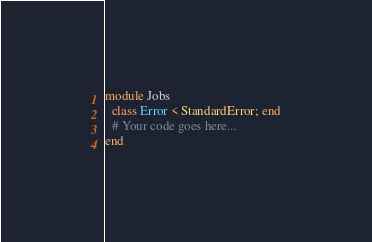<code> <loc_0><loc_0><loc_500><loc_500><_Ruby_>module Jobs
  class Error < StandardError; end
  # Your code goes here...
end
</code> 